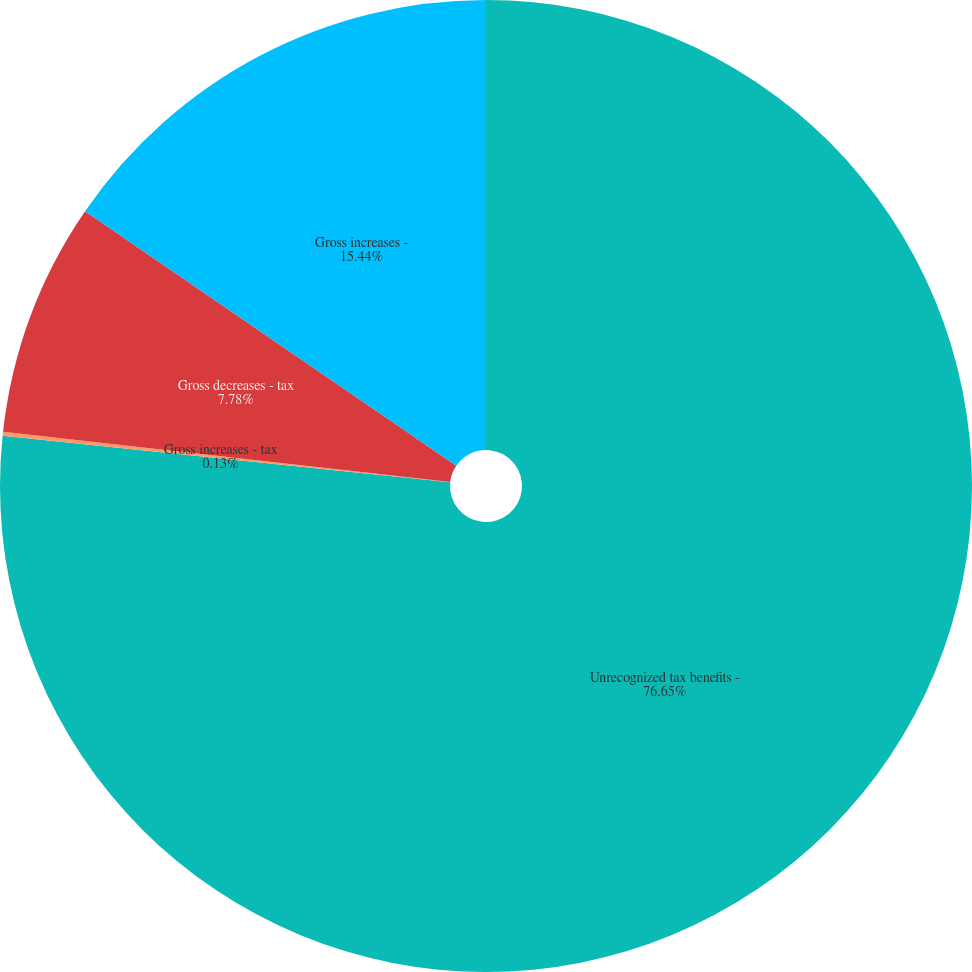<chart> <loc_0><loc_0><loc_500><loc_500><pie_chart><fcel>Unrecognized tax benefits -<fcel>Gross increases - tax<fcel>Gross decreases - tax<fcel>Gross increases -<nl><fcel>76.65%<fcel>0.13%<fcel>7.78%<fcel>15.44%<nl></chart> 